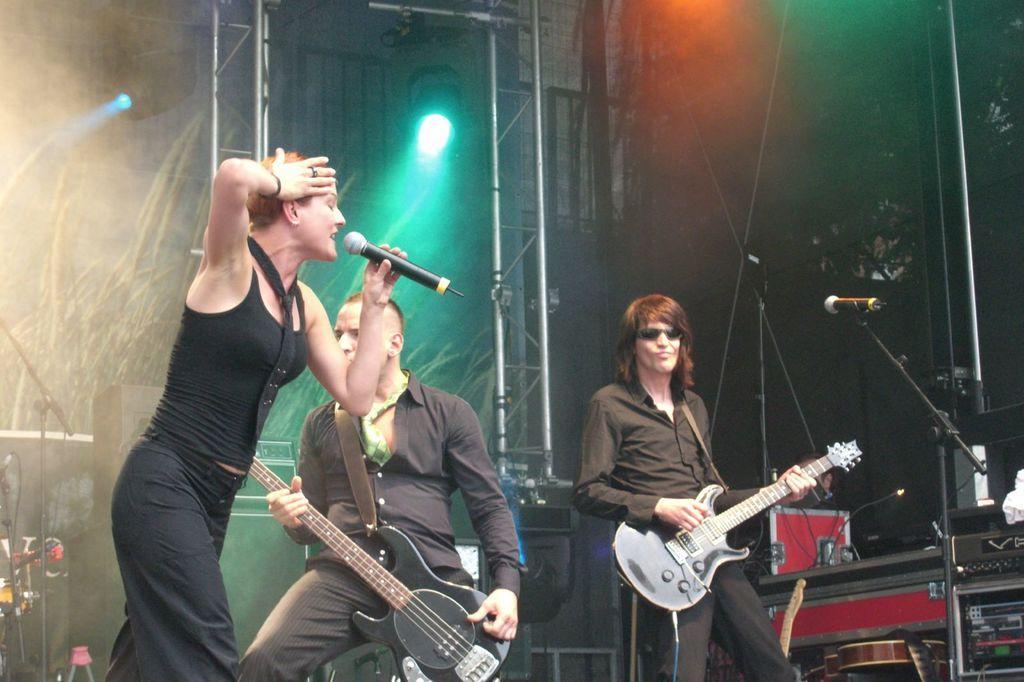How would you summarize this image in a sentence or two? This woman is holding a mic. This 2 mans are holding a guitar. This is a mic with holder. This is a focusing light. 